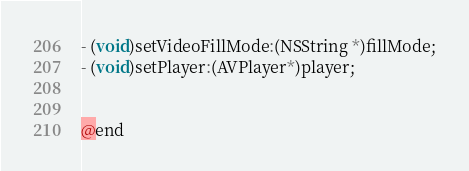<code> <loc_0><loc_0><loc_500><loc_500><_C_>- (void)setVideoFillMode:(NSString *)fillMode;
- (void)setPlayer:(AVPlayer*)player;


@end
</code> 